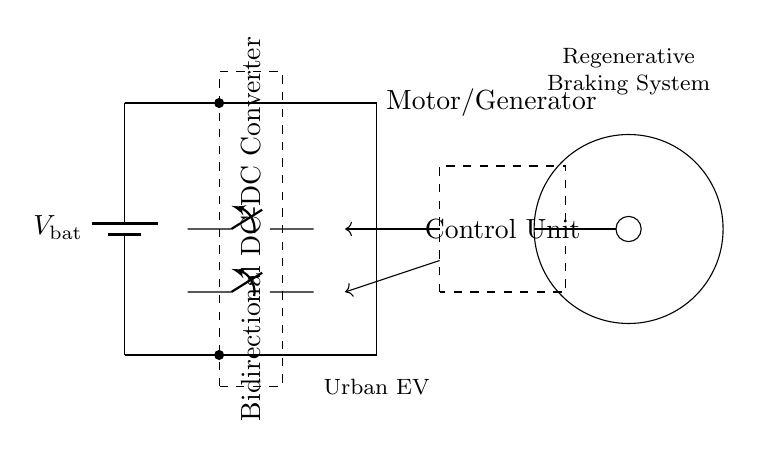What type of system is depicted in this circuit? The circuit represents a regenerative braking system, indicated by the label at the top of the diagram.
Answer: regenerative braking system What component is used to control the flow between the battery and the motor? The diagram shows a bidirectional DC-DC converter marked inside a dashed rectangle, which manages the energy flow.
Answer: bidirectional DC-DC converter How many switches are present in the circuit? There are two switches shown in the diagram, indicated by the two ospst symbols in the central section of the circuit.
Answer: two What does the control unit do in this circuit? The control unit, illustrated in a dashed rectangle on the right, provides control signals to manage the operation of the motor and switches.
Answer: manages control signals What is the main purpose of the motor/generator in this circuit? The motor/generator converts electrical energy to kinetic energy during acceleration and reverses this process during braking to regenerate energy.
Answer: energy conversion What is the primary function of regenerative braking in electric vehicles? Regenerative braking allows the vehicle to capture kinetic energy during braking and store it back in the battery, enhancing overall efficiency.
Answer: energy recovery What does the notation V_bat signify in this circuit? The notation V_bat represents the voltage of the battery, which supplies power to the regenerative braking system.
Answer: voltage of the battery 